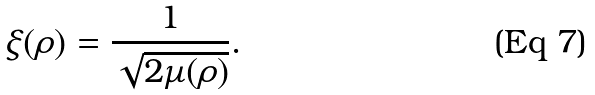Convert formula to latex. <formula><loc_0><loc_0><loc_500><loc_500>\xi ( \rho ) = \frac { 1 } { \sqrt { 2 \mu ( \rho ) } } .</formula> 